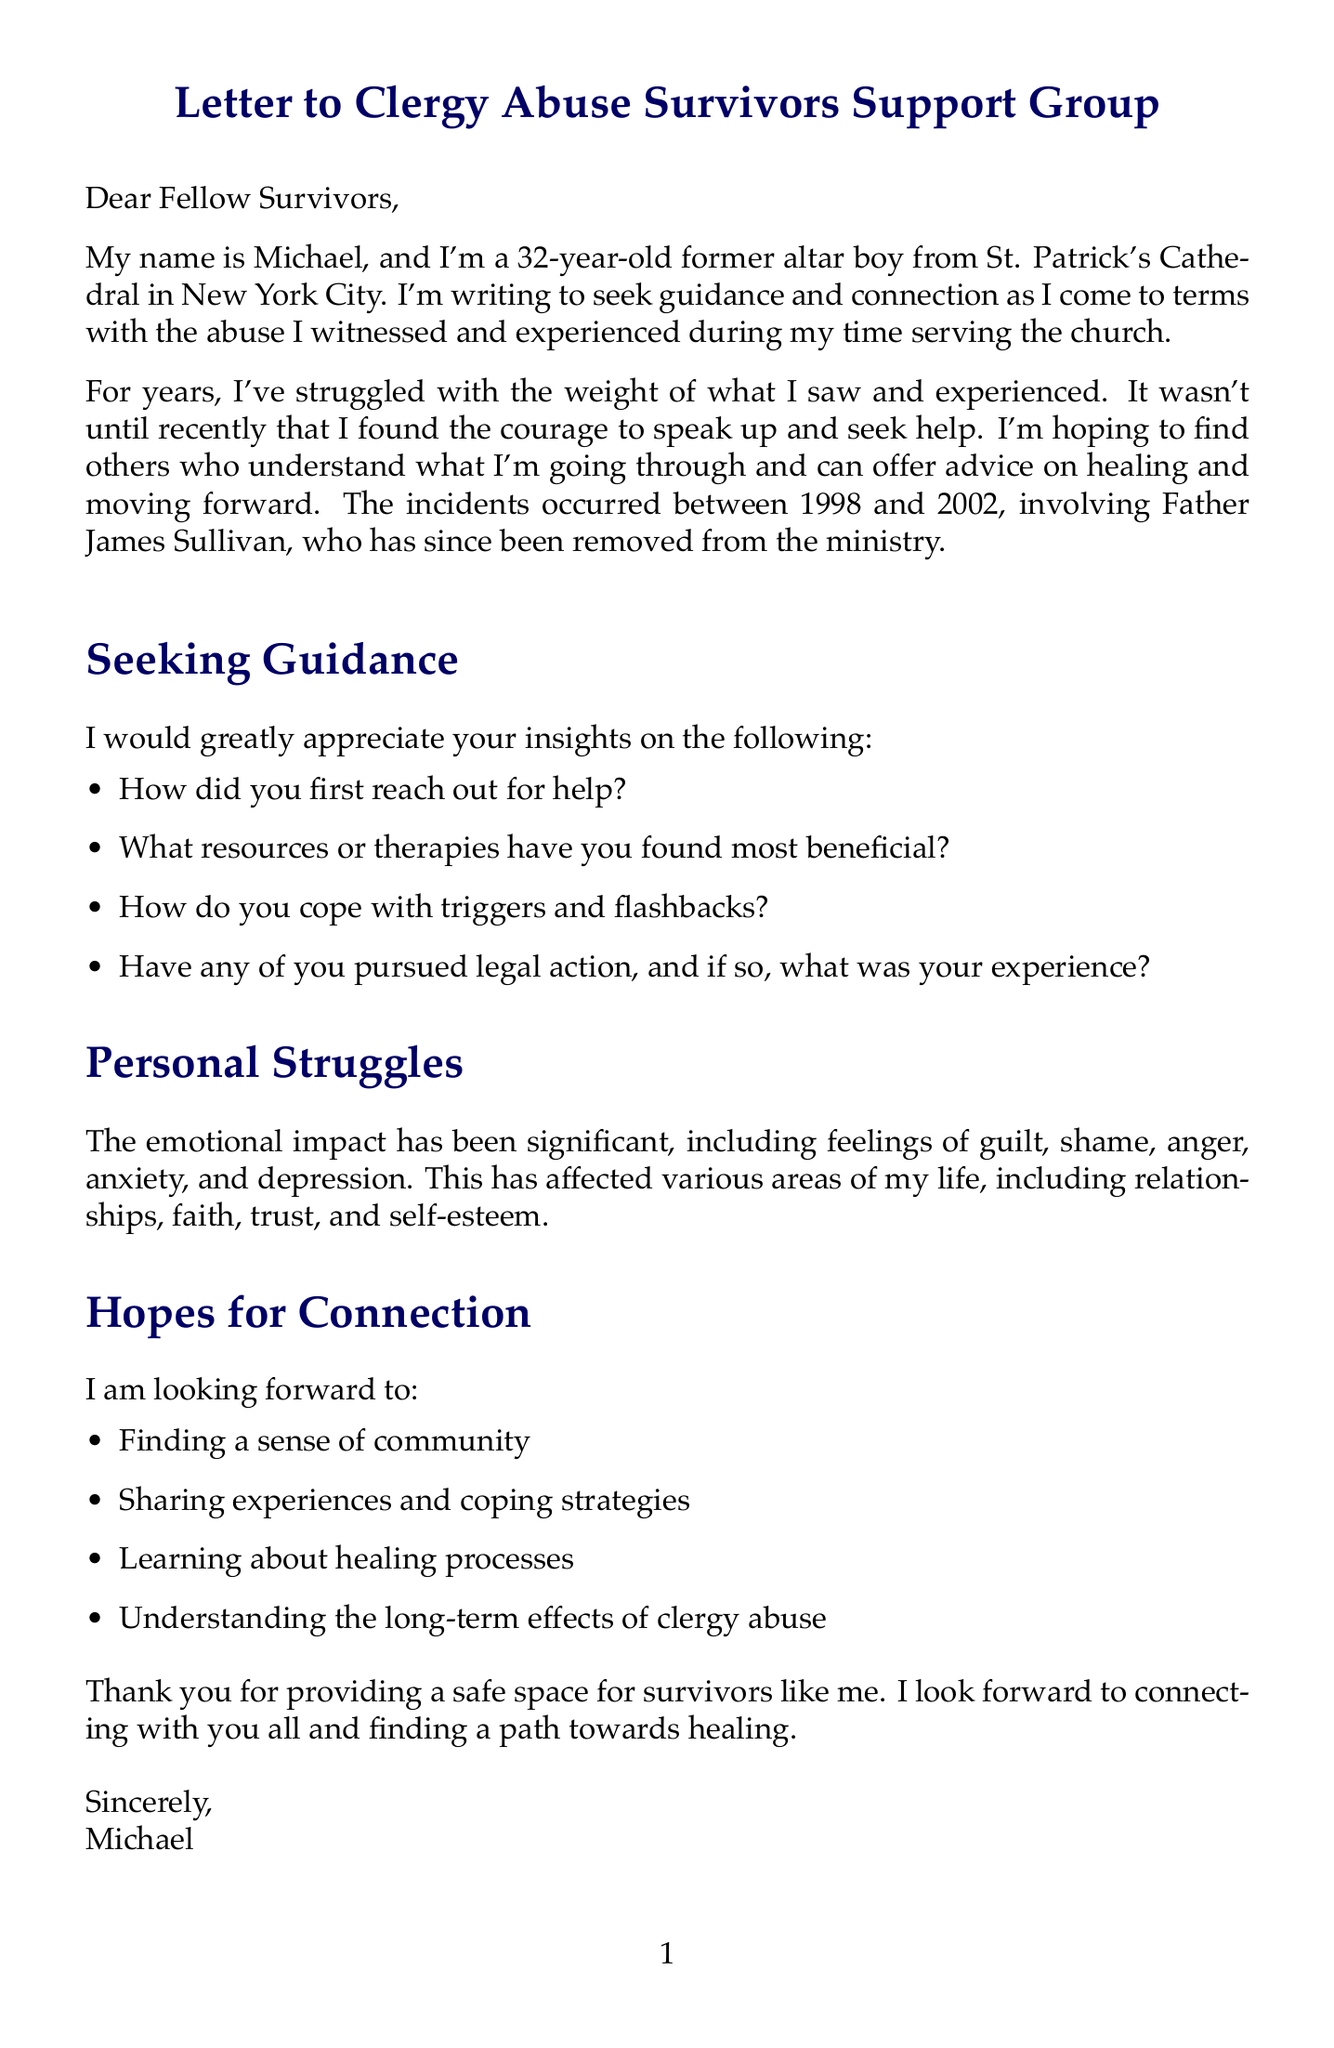What is the name of the writer? The writer's name mentioned in the document is Michael.
Answer: Michael What is the purpose of the letter? The writer seeks guidance and connection regarding the abuse experienced and witnessed.
Answer: guidance and connection Which church is mentioned in the letter? The specific church referred to in the document is St. Patrick's Cathedral.
Answer: St. Patrick's Cathedral What time period does the writer refer to for the incidents? The incidents mentioned occurred between 1998 and 2002.
Answer: 1998 and 2002 What is one of the emotional impacts listed by the writer? One of the emotional impacts mentioned is guilt.
Answer: guilt What type of therapy is listed as an option? One therapy option included is Cognitive Behavioral Therapy (CBT).
Answer: Cognitive Behavioral Therapy (CBT) What organization is recommended for support in the letter? A recommended organization for support is SNAP.
Answer: SNAP What is the name of one recommended book? One of the recommended books is The Courage to Heal.
Answer: The Courage to Heal What legal act is referenced in the document? The document references the New York Child Victims Act.
Answer: New York Child Victims Act 